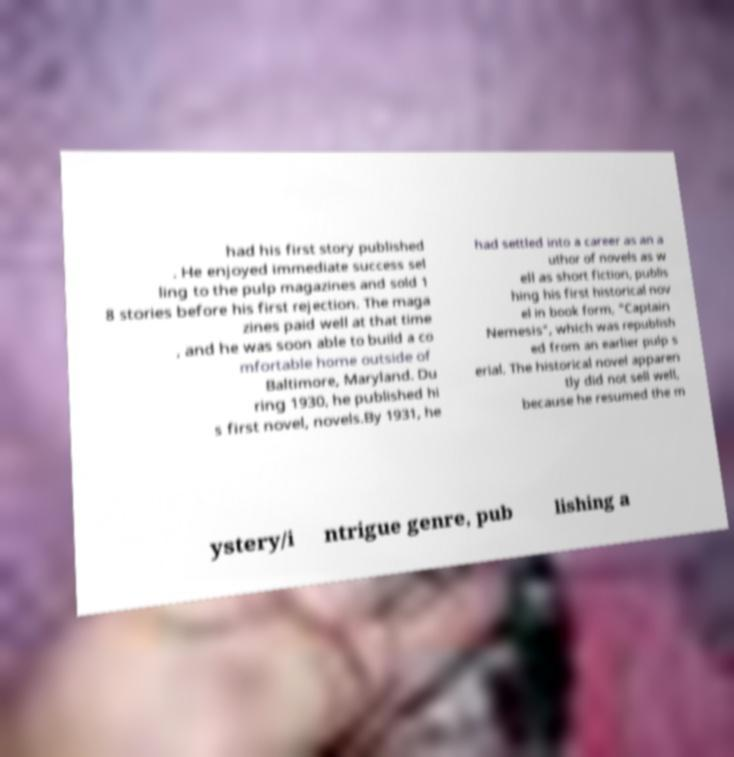I need the written content from this picture converted into text. Can you do that? had his first story published . He enjoyed immediate success sel ling to the pulp magazines and sold 1 8 stories before his first rejection. The maga zines paid well at that time , and he was soon able to build a co mfortable home outside of Baltimore, Maryland. Du ring 1930, he published hi s first novel, novels.By 1931, he had settled into a career as an a uthor of novels as w ell as short fiction, publis hing his first historical nov el in book form, "Captain Nemesis", which was republish ed from an earlier pulp s erial. The historical novel apparen tly did not sell well, because he resumed the m ystery/i ntrigue genre, pub lishing a 